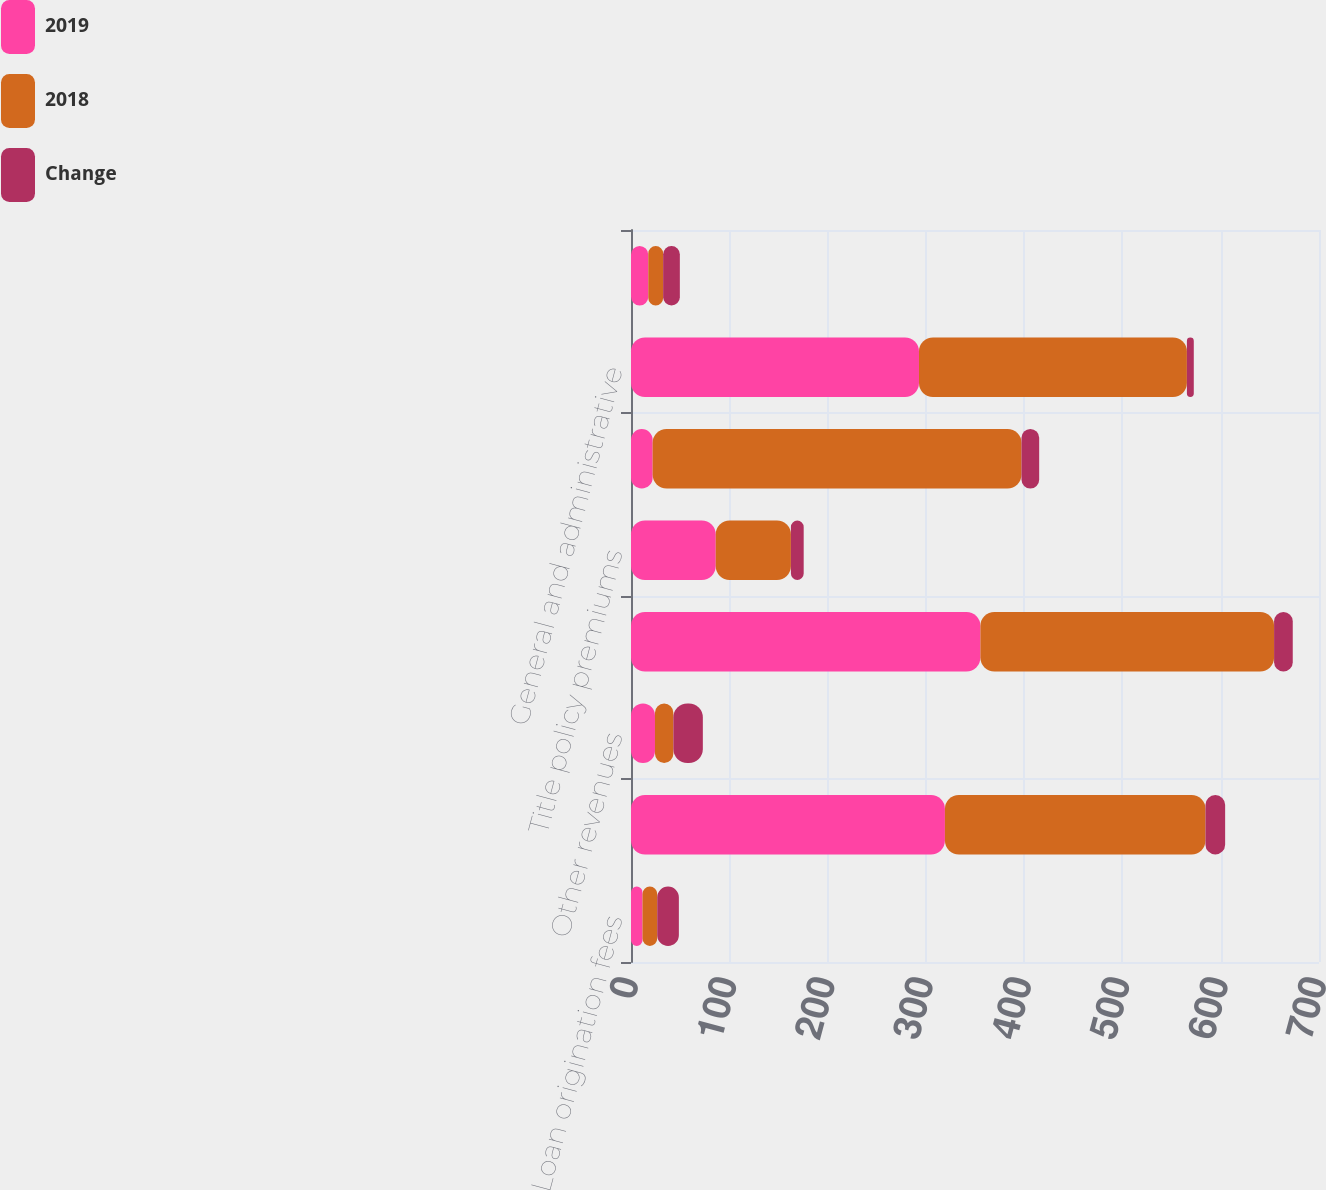Convert chart to OTSL. <chart><loc_0><loc_0><loc_500><loc_500><stacked_bar_chart><ecel><fcel>Loan origination fees<fcel>Sale of servicing rights and<fcel>Other revenues<fcel>Total mortgage operations<fcel>Title policy premiums<fcel>Total revenues<fcel>General and administrative<fcel>Other (income) expense<nl><fcel>2019<fcel>11.7<fcel>319.4<fcel>24.4<fcel>355.5<fcel>86.2<fcel>22<fcel>293<fcel>17.6<nl><fcel>2018<fcel>15<fcel>265.1<fcel>18.7<fcel>298.8<fcel>76.5<fcel>375.3<fcel>272.6<fcel>15.1<nl><fcel>Change<fcel>22<fcel>20<fcel>30<fcel>19<fcel>13<fcel>18<fcel>7<fcel>17<nl></chart> 